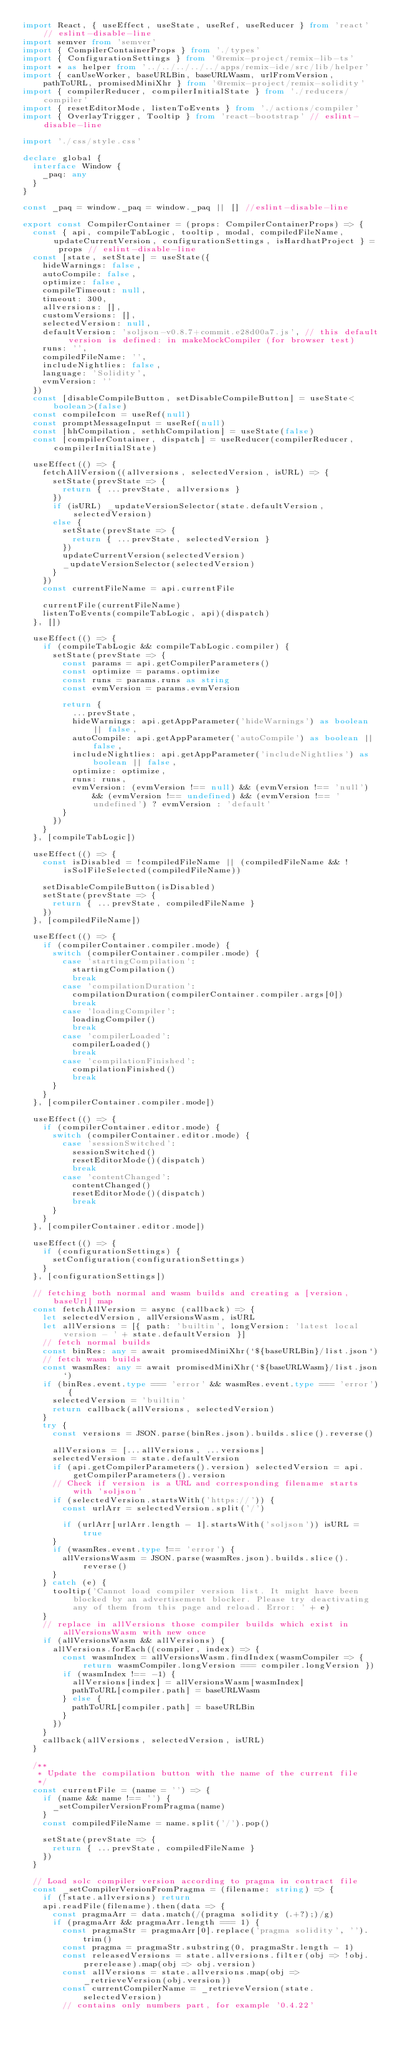<code> <loc_0><loc_0><loc_500><loc_500><_TypeScript_>import React, { useEffect, useState, useRef, useReducer } from 'react' // eslint-disable-line
import semver from 'semver'
import { CompilerContainerProps } from './types'
import { ConfigurationSettings } from '@remix-project/remix-lib-ts'
import * as helper from '../../../../../apps/remix-ide/src/lib/helper'
import { canUseWorker, baseURLBin, baseURLWasm, urlFromVersion, pathToURL, promisedMiniXhr } from '@remix-project/remix-solidity'
import { compilerReducer, compilerInitialState } from './reducers/compiler'
import { resetEditorMode, listenToEvents } from './actions/compiler'
import { OverlayTrigger, Tooltip } from 'react-bootstrap' // eslint-disable-line

import './css/style.css'

declare global {
  interface Window {
    _paq: any
  }
}

const _paq = window._paq = window._paq || [] //eslint-disable-line

export const CompilerContainer = (props: CompilerContainerProps) => {
  const { api, compileTabLogic, tooltip, modal, compiledFileName, updateCurrentVersion, configurationSettings, isHardhatProject } = props // eslint-disable-line
  const [state, setState] = useState({
    hideWarnings: false,
    autoCompile: false,
    optimize: false,
    compileTimeout: null,
    timeout: 300,
    allversions: [],
    customVersions: [],
    selectedVersion: null,
    defaultVersion: 'soljson-v0.8.7+commit.e28d00a7.js', // this default version is defined: in makeMockCompiler (for browser test)
    runs: '',
    compiledFileName: '',
    includeNightlies: false,
    language: 'Solidity',
    evmVersion: ''
  })
  const [disableCompileButton, setDisableCompileButton] = useState<boolean>(false)
  const compileIcon = useRef(null)
  const promptMessageInput = useRef(null)
  const [hhCompilation, sethhCompilation] = useState(false)
  const [compilerContainer, dispatch] = useReducer(compilerReducer, compilerInitialState)

  useEffect(() => {
    fetchAllVersion((allversions, selectedVersion, isURL) => {
      setState(prevState => {
        return { ...prevState, allversions }
      })
      if (isURL) _updateVersionSelector(state.defaultVersion, selectedVersion)
      else {
        setState(prevState => {
          return { ...prevState, selectedVersion }
        })
        updateCurrentVersion(selectedVersion)
        _updateVersionSelector(selectedVersion)
      }
    })
    const currentFileName = api.currentFile

    currentFile(currentFileName)
    listenToEvents(compileTabLogic, api)(dispatch)
  }, [])

  useEffect(() => {
    if (compileTabLogic && compileTabLogic.compiler) {
      setState(prevState => {
        const params = api.getCompilerParameters()
        const optimize = params.optimize
        const runs = params.runs as string
        const evmVersion = params.evmVersion

        return {
          ...prevState,
          hideWarnings: api.getAppParameter('hideWarnings') as boolean || false,
          autoCompile: api.getAppParameter('autoCompile') as boolean || false,
          includeNightlies: api.getAppParameter('includeNightlies') as boolean || false,
          optimize: optimize,
          runs: runs,
          evmVersion: (evmVersion !== null) && (evmVersion !== 'null') && (evmVersion !== undefined) && (evmVersion !== 'undefined') ? evmVersion : 'default'
        }
      })
    }
  }, [compileTabLogic])

  useEffect(() => {
    const isDisabled = !compiledFileName || (compiledFileName && !isSolFileSelected(compiledFileName))

    setDisableCompileButton(isDisabled)
    setState(prevState => {
      return { ...prevState, compiledFileName }
    })
  }, [compiledFileName])

  useEffect(() => {
    if (compilerContainer.compiler.mode) {
      switch (compilerContainer.compiler.mode) {
        case 'startingCompilation':
          startingCompilation()
          break
        case 'compilationDuration':
          compilationDuration(compilerContainer.compiler.args[0])
          break
        case 'loadingCompiler':
          loadingCompiler()
          break
        case 'compilerLoaded':
          compilerLoaded()
          break
        case 'compilationFinished':
          compilationFinished()
          break
      }
    }
  }, [compilerContainer.compiler.mode])

  useEffect(() => {
    if (compilerContainer.editor.mode) {
      switch (compilerContainer.editor.mode) {
        case 'sessionSwitched':
          sessionSwitched()
          resetEditorMode()(dispatch)
          break
        case 'contentChanged':
          contentChanged()
          resetEditorMode()(dispatch)
          break
      }
    }
  }, [compilerContainer.editor.mode])

  useEffect(() => {
    if (configurationSettings) {
      setConfiguration(configurationSettings)
    }
  }, [configurationSettings])

  // fetching both normal and wasm builds and creating a [version, baseUrl] map
  const fetchAllVersion = async (callback) => {
    let selectedVersion, allVersionsWasm, isURL
    let allVersions = [{ path: 'builtin', longVersion: 'latest local version - ' + state.defaultVersion }]
    // fetch normal builds
    const binRes: any = await promisedMiniXhr(`${baseURLBin}/list.json`)
    // fetch wasm builds
    const wasmRes: any = await promisedMiniXhr(`${baseURLWasm}/list.json`)
    if (binRes.event.type === 'error' && wasmRes.event.type === 'error') {
      selectedVersion = 'builtin'
      return callback(allVersions, selectedVersion)
    }
    try {
      const versions = JSON.parse(binRes.json).builds.slice().reverse()

      allVersions = [...allVersions, ...versions]
      selectedVersion = state.defaultVersion
      if (api.getCompilerParameters().version) selectedVersion = api.getCompilerParameters().version
      // Check if version is a URL and corresponding filename starts with 'soljson'
      if (selectedVersion.startsWith('https://')) {
        const urlArr = selectedVersion.split('/')

        if (urlArr[urlArr.length - 1].startsWith('soljson')) isURL = true
      }
      if (wasmRes.event.type !== 'error') {
        allVersionsWasm = JSON.parse(wasmRes.json).builds.slice().reverse()
      }
    } catch (e) {
      tooltip('Cannot load compiler version list. It might have been blocked by an advertisement blocker. Please try deactivating any of them from this page and reload. Error: ' + e)
    }
    // replace in allVersions those compiler builds which exist in allVersionsWasm with new once
    if (allVersionsWasm && allVersions) {
      allVersions.forEach((compiler, index) => {
        const wasmIndex = allVersionsWasm.findIndex(wasmCompiler => { return wasmCompiler.longVersion === compiler.longVersion })
        if (wasmIndex !== -1) {
          allVersions[index] = allVersionsWasm[wasmIndex]
          pathToURL[compiler.path] = baseURLWasm
        } else {
          pathToURL[compiler.path] = baseURLBin
        }
      })
    }
    callback(allVersions, selectedVersion, isURL)
  }

  /**
   * Update the compilation button with the name of the current file
   */
  const currentFile = (name = '') => {
    if (name && name !== '') {
      _setCompilerVersionFromPragma(name)
    }
    const compiledFileName = name.split('/').pop()

    setState(prevState => {
      return { ...prevState, compiledFileName }
    })
  }

  // Load solc compiler version according to pragma in contract file
  const _setCompilerVersionFromPragma = (filename: string) => {
    if (!state.allversions) return
    api.readFile(filename).then(data => {
      const pragmaArr = data.match(/(pragma solidity (.+?);)/g)
      if (pragmaArr && pragmaArr.length === 1) {
        const pragmaStr = pragmaArr[0].replace('pragma solidity', '').trim()
        const pragma = pragmaStr.substring(0, pragmaStr.length - 1)
        const releasedVersions = state.allversions.filter(obj => !obj.prerelease).map(obj => obj.version)
        const allVersions = state.allversions.map(obj => _retrieveVersion(obj.version))
        const currentCompilerName = _retrieveVersion(state.selectedVersion)
        // contains only numbers part, for example '0.4.22'</code> 